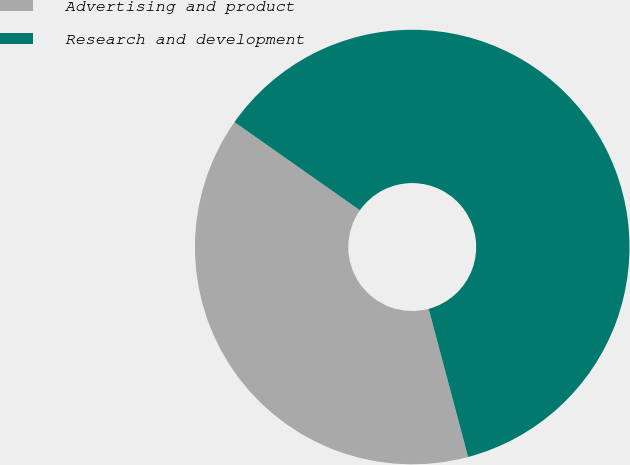<chart> <loc_0><loc_0><loc_500><loc_500><pie_chart><fcel>Advertising and product<fcel>Research and development<nl><fcel>38.89%<fcel>61.11%<nl></chart> 